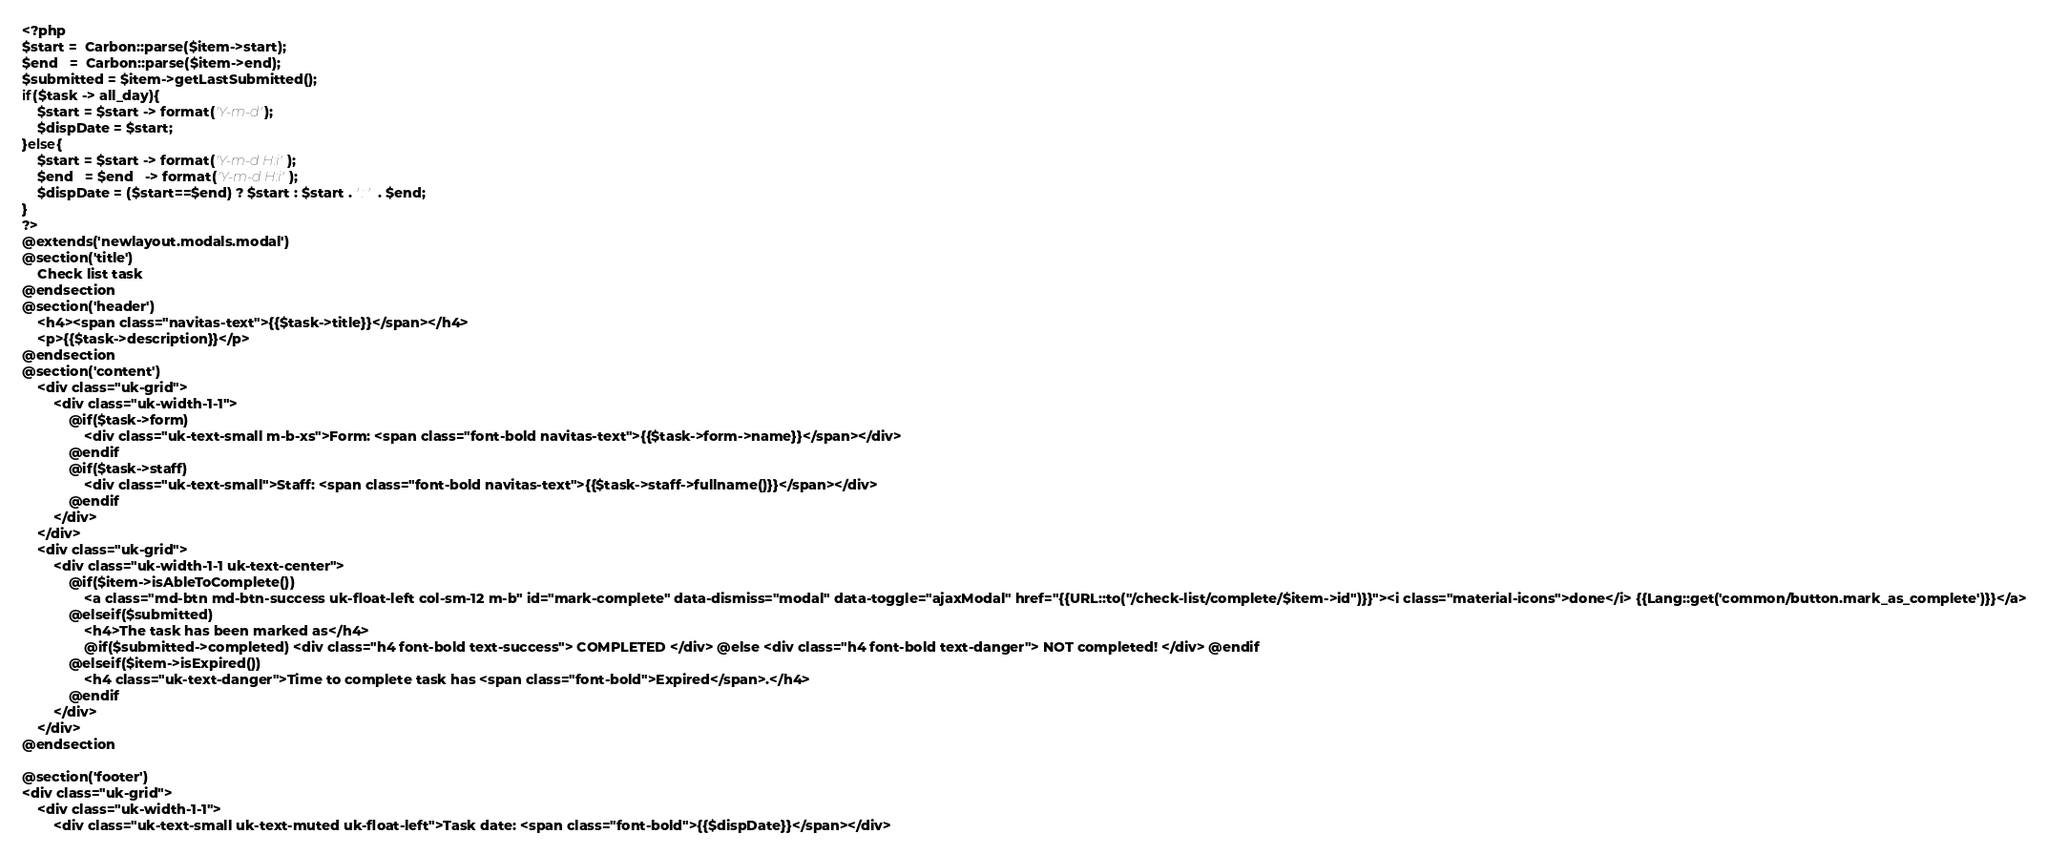Convert code to text. <code><loc_0><loc_0><loc_500><loc_500><_PHP_><?php
$start =  Carbon::parse($item->start);
$end   =  Carbon::parse($item->end);
$submitted = $item->getLastSubmitted();
if($task -> all_day){
    $start = $start -> format('Y-m-d');
    $dispDate = $start;
}else{
    $start = $start -> format('Y-m-d H:i');
    $end   = $end   -> format('Y-m-d H:i');
    $dispDate = ($start==$end) ? $start : $start . ' : ' . $end;
}
?>
@extends('newlayout.modals.modal')
@section('title')
    Check list task
@endsection
@section('header')
    <h4><span class="navitas-text">{{$task->title}}</span></h4>
    <p>{{$task->description}}</p>
@endsection
@section('content')
    <div class="uk-grid">
        <div class="uk-width-1-1">
            @if($task->form)
                <div class="uk-text-small m-b-xs">Form: <span class="font-bold navitas-text">{{$task->form->name}}</span></div>
            @endif
            @if($task->staff)
                <div class="uk-text-small">Staff: <span class="font-bold navitas-text">{{$task->staff->fullname()}}</span></div>
            @endif
        </div>
    </div>
    <div class="uk-grid">
        <div class="uk-width-1-1 uk-text-center">
            @if($item->isAbleToComplete())
                <a class="md-btn md-btn-success uk-float-left col-sm-12 m-b" id="mark-complete" data-dismiss="modal" data-toggle="ajaxModal" href="{{URL::to("/check-list/complete/$item->id")}}"><i class="material-icons">done</i> {{Lang::get('common/button.mark_as_complete')}}</a>
            @elseif($submitted)
                <h4>The task has been marked as</h4>
                @if($submitted->completed) <div class="h4 font-bold text-success"> COMPLETED </div> @else <div class="h4 font-bold text-danger"> NOT completed! </div> @endif
            @elseif($item->isExpired())
                <h4 class="uk-text-danger">Time to complete task has <span class="font-bold">Expired</span>.</h4>
            @endif
        </div>
    </div>
@endsection

@section('footer')
<div class="uk-grid">
    <div class="uk-width-1-1">
        <div class="uk-text-small uk-text-muted uk-float-left">Task date: <span class="font-bold">{{$dispDate}}</span></div></code> 